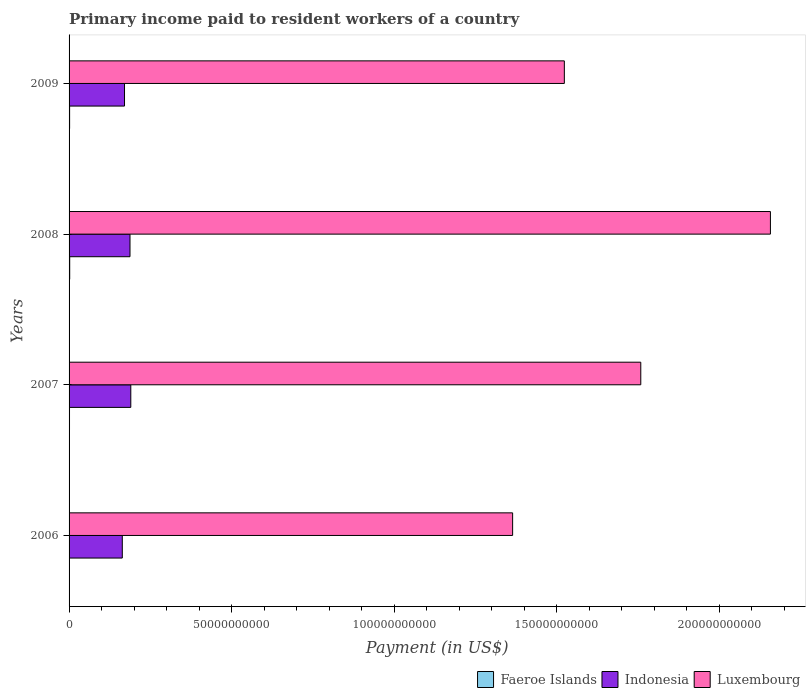How many groups of bars are there?
Your answer should be very brief. 4. Are the number of bars per tick equal to the number of legend labels?
Give a very brief answer. Yes. Are the number of bars on each tick of the Y-axis equal?
Make the answer very short. Yes. How many bars are there on the 4th tick from the top?
Give a very brief answer. 3. How many bars are there on the 3rd tick from the bottom?
Offer a very short reply. 3. What is the amount paid to workers in Luxembourg in 2006?
Provide a succinct answer. 1.36e+11. Across all years, what is the maximum amount paid to workers in Indonesia?
Make the answer very short. 1.90e+1. Across all years, what is the minimum amount paid to workers in Indonesia?
Offer a very short reply. 1.64e+1. In which year was the amount paid to workers in Luxembourg maximum?
Provide a short and direct response. 2008. In which year was the amount paid to workers in Luxembourg minimum?
Offer a very short reply. 2006. What is the total amount paid to workers in Faeroe Islands in the graph?
Provide a succinct answer. 5.95e+08. What is the difference between the amount paid to workers in Luxembourg in 2006 and that in 2009?
Give a very brief answer. -1.59e+1. What is the difference between the amount paid to workers in Indonesia in 2006 and the amount paid to workers in Luxembourg in 2008?
Offer a very short reply. -1.99e+11. What is the average amount paid to workers in Indonesia per year?
Your answer should be very brief. 1.78e+1. In the year 2009, what is the difference between the amount paid to workers in Faeroe Islands and amount paid to workers in Luxembourg?
Give a very brief answer. -1.52e+11. What is the ratio of the amount paid to workers in Luxembourg in 2006 to that in 2009?
Give a very brief answer. 0.9. What is the difference between the highest and the second highest amount paid to workers in Indonesia?
Your answer should be compact. 2.47e+08. What is the difference between the highest and the lowest amount paid to workers in Luxembourg?
Make the answer very short. 7.93e+1. Is the sum of the amount paid to workers in Indonesia in 2007 and 2009 greater than the maximum amount paid to workers in Luxembourg across all years?
Ensure brevity in your answer.  No. What does the 2nd bar from the top in 2009 represents?
Provide a succinct answer. Indonesia. What does the 1st bar from the bottom in 2008 represents?
Your answer should be compact. Faeroe Islands. Is it the case that in every year, the sum of the amount paid to workers in Luxembourg and amount paid to workers in Faeroe Islands is greater than the amount paid to workers in Indonesia?
Provide a short and direct response. Yes. What is the difference between two consecutive major ticks on the X-axis?
Offer a terse response. 5.00e+1. Where does the legend appear in the graph?
Your response must be concise. Bottom right. How many legend labels are there?
Provide a short and direct response. 3. What is the title of the graph?
Your answer should be very brief. Primary income paid to resident workers of a country. What is the label or title of the X-axis?
Provide a short and direct response. Payment (in US$). What is the label or title of the Y-axis?
Offer a very short reply. Years. What is the Payment (in US$) in Faeroe Islands in 2006?
Ensure brevity in your answer.  9.96e+07. What is the Payment (in US$) of Indonesia in 2006?
Give a very brief answer. 1.64e+1. What is the Payment (in US$) in Luxembourg in 2006?
Make the answer very short. 1.36e+11. What is the Payment (in US$) in Faeroe Islands in 2007?
Provide a short and direct response. 1.36e+08. What is the Payment (in US$) of Indonesia in 2007?
Give a very brief answer. 1.90e+1. What is the Payment (in US$) in Luxembourg in 2007?
Give a very brief answer. 1.76e+11. What is the Payment (in US$) in Faeroe Islands in 2008?
Your response must be concise. 1.92e+08. What is the Payment (in US$) in Indonesia in 2008?
Your answer should be very brief. 1.87e+1. What is the Payment (in US$) of Luxembourg in 2008?
Offer a terse response. 2.16e+11. What is the Payment (in US$) of Faeroe Islands in 2009?
Offer a very short reply. 1.67e+08. What is the Payment (in US$) in Indonesia in 2009?
Keep it short and to the point. 1.71e+1. What is the Payment (in US$) of Luxembourg in 2009?
Provide a short and direct response. 1.52e+11. Across all years, what is the maximum Payment (in US$) of Faeroe Islands?
Your answer should be compact. 1.92e+08. Across all years, what is the maximum Payment (in US$) in Indonesia?
Provide a succinct answer. 1.90e+1. Across all years, what is the maximum Payment (in US$) of Luxembourg?
Give a very brief answer. 2.16e+11. Across all years, what is the minimum Payment (in US$) of Faeroe Islands?
Your answer should be very brief. 9.96e+07. Across all years, what is the minimum Payment (in US$) in Indonesia?
Provide a succinct answer. 1.64e+1. Across all years, what is the minimum Payment (in US$) of Luxembourg?
Make the answer very short. 1.36e+11. What is the total Payment (in US$) in Faeroe Islands in the graph?
Offer a very short reply. 5.95e+08. What is the total Payment (in US$) in Indonesia in the graph?
Give a very brief answer. 7.12e+1. What is the total Payment (in US$) of Luxembourg in the graph?
Your response must be concise. 6.81e+11. What is the difference between the Payment (in US$) of Faeroe Islands in 2006 and that in 2007?
Your answer should be very brief. -3.60e+07. What is the difference between the Payment (in US$) in Indonesia in 2006 and that in 2007?
Provide a succinct answer. -2.62e+09. What is the difference between the Payment (in US$) in Luxembourg in 2006 and that in 2007?
Provide a succinct answer. -3.94e+1. What is the difference between the Payment (in US$) of Faeroe Islands in 2006 and that in 2008?
Provide a succinct answer. -9.29e+07. What is the difference between the Payment (in US$) of Indonesia in 2006 and that in 2008?
Offer a very short reply. -2.37e+09. What is the difference between the Payment (in US$) in Luxembourg in 2006 and that in 2008?
Keep it short and to the point. -7.93e+1. What is the difference between the Payment (in US$) in Faeroe Islands in 2006 and that in 2009?
Give a very brief answer. -6.74e+07. What is the difference between the Payment (in US$) in Indonesia in 2006 and that in 2009?
Your response must be concise. -6.84e+08. What is the difference between the Payment (in US$) of Luxembourg in 2006 and that in 2009?
Give a very brief answer. -1.59e+1. What is the difference between the Payment (in US$) of Faeroe Islands in 2007 and that in 2008?
Provide a succinct answer. -5.69e+07. What is the difference between the Payment (in US$) in Indonesia in 2007 and that in 2008?
Offer a very short reply. 2.47e+08. What is the difference between the Payment (in US$) in Luxembourg in 2007 and that in 2008?
Your answer should be compact. -3.99e+1. What is the difference between the Payment (in US$) of Faeroe Islands in 2007 and that in 2009?
Your answer should be compact. -3.14e+07. What is the difference between the Payment (in US$) in Indonesia in 2007 and that in 2009?
Your answer should be compact. 1.93e+09. What is the difference between the Payment (in US$) in Luxembourg in 2007 and that in 2009?
Your answer should be very brief. 2.35e+1. What is the difference between the Payment (in US$) in Faeroe Islands in 2008 and that in 2009?
Make the answer very short. 2.55e+07. What is the difference between the Payment (in US$) in Indonesia in 2008 and that in 2009?
Provide a short and direct response. 1.69e+09. What is the difference between the Payment (in US$) of Luxembourg in 2008 and that in 2009?
Give a very brief answer. 6.34e+1. What is the difference between the Payment (in US$) in Faeroe Islands in 2006 and the Payment (in US$) in Indonesia in 2007?
Your answer should be compact. -1.89e+1. What is the difference between the Payment (in US$) of Faeroe Islands in 2006 and the Payment (in US$) of Luxembourg in 2007?
Ensure brevity in your answer.  -1.76e+11. What is the difference between the Payment (in US$) of Indonesia in 2006 and the Payment (in US$) of Luxembourg in 2007?
Your answer should be compact. -1.60e+11. What is the difference between the Payment (in US$) of Faeroe Islands in 2006 and the Payment (in US$) of Indonesia in 2008?
Provide a succinct answer. -1.86e+1. What is the difference between the Payment (in US$) of Faeroe Islands in 2006 and the Payment (in US$) of Luxembourg in 2008?
Ensure brevity in your answer.  -2.16e+11. What is the difference between the Payment (in US$) in Indonesia in 2006 and the Payment (in US$) in Luxembourg in 2008?
Offer a terse response. -1.99e+11. What is the difference between the Payment (in US$) of Faeroe Islands in 2006 and the Payment (in US$) of Indonesia in 2009?
Provide a short and direct response. -1.70e+1. What is the difference between the Payment (in US$) in Faeroe Islands in 2006 and the Payment (in US$) in Luxembourg in 2009?
Your response must be concise. -1.52e+11. What is the difference between the Payment (in US$) in Indonesia in 2006 and the Payment (in US$) in Luxembourg in 2009?
Give a very brief answer. -1.36e+11. What is the difference between the Payment (in US$) of Faeroe Islands in 2007 and the Payment (in US$) of Indonesia in 2008?
Your response must be concise. -1.86e+1. What is the difference between the Payment (in US$) in Faeroe Islands in 2007 and the Payment (in US$) in Luxembourg in 2008?
Keep it short and to the point. -2.16e+11. What is the difference between the Payment (in US$) in Indonesia in 2007 and the Payment (in US$) in Luxembourg in 2008?
Keep it short and to the point. -1.97e+11. What is the difference between the Payment (in US$) of Faeroe Islands in 2007 and the Payment (in US$) of Indonesia in 2009?
Provide a short and direct response. -1.69e+1. What is the difference between the Payment (in US$) in Faeroe Islands in 2007 and the Payment (in US$) in Luxembourg in 2009?
Offer a terse response. -1.52e+11. What is the difference between the Payment (in US$) of Indonesia in 2007 and the Payment (in US$) of Luxembourg in 2009?
Provide a short and direct response. -1.33e+11. What is the difference between the Payment (in US$) in Faeroe Islands in 2008 and the Payment (in US$) in Indonesia in 2009?
Ensure brevity in your answer.  -1.69e+1. What is the difference between the Payment (in US$) of Faeroe Islands in 2008 and the Payment (in US$) of Luxembourg in 2009?
Your response must be concise. -1.52e+11. What is the difference between the Payment (in US$) in Indonesia in 2008 and the Payment (in US$) in Luxembourg in 2009?
Your response must be concise. -1.34e+11. What is the average Payment (in US$) of Faeroe Islands per year?
Provide a succinct answer. 1.49e+08. What is the average Payment (in US$) of Indonesia per year?
Your response must be concise. 1.78e+1. What is the average Payment (in US$) of Luxembourg per year?
Give a very brief answer. 1.70e+11. In the year 2006, what is the difference between the Payment (in US$) in Faeroe Islands and Payment (in US$) in Indonesia?
Keep it short and to the point. -1.63e+1. In the year 2006, what is the difference between the Payment (in US$) in Faeroe Islands and Payment (in US$) in Luxembourg?
Offer a very short reply. -1.36e+11. In the year 2006, what is the difference between the Payment (in US$) of Indonesia and Payment (in US$) of Luxembourg?
Your response must be concise. -1.20e+11. In the year 2007, what is the difference between the Payment (in US$) of Faeroe Islands and Payment (in US$) of Indonesia?
Offer a very short reply. -1.89e+1. In the year 2007, what is the difference between the Payment (in US$) in Faeroe Islands and Payment (in US$) in Luxembourg?
Your answer should be very brief. -1.76e+11. In the year 2007, what is the difference between the Payment (in US$) of Indonesia and Payment (in US$) of Luxembourg?
Your answer should be very brief. -1.57e+11. In the year 2008, what is the difference between the Payment (in US$) of Faeroe Islands and Payment (in US$) of Indonesia?
Ensure brevity in your answer.  -1.86e+1. In the year 2008, what is the difference between the Payment (in US$) in Faeroe Islands and Payment (in US$) in Luxembourg?
Your response must be concise. -2.16e+11. In the year 2008, what is the difference between the Payment (in US$) of Indonesia and Payment (in US$) of Luxembourg?
Your response must be concise. -1.97e+11. In the year 2009, what is the difference between the Payment (in US$) of Faeroe Islands and Payment (in US$) of Indonesia?
Make the answer very short. -1.69e+1. In the year 2009, what is the difference between the Payment (in US$) in Faeroe Islands and Payment (in US$) in Luxembourg?
Provide a succinct answer. -1.52e+11. In the year 2009, what is the difference between the Payment (in US$) of Indonesia and Payment (in US$) of Luxembourg?
Your answer should be compact. -1.35e+11. What is the ratio of the Payment (in US$) in Faeroe Islands in 2006 to that in 2007?
Keep it short and to the point. 0.73. What is the ratio of the Payment (in US$) of Indonesia in 2006 to that in 2007?
Your response must be concise. 0.86. What is the ratio of the Payment (in US$) of Luxembourg in 2006 to that in 2007?
Give a very brief answer. 0.78. What is the ratio of the Payment (in US$) of Faeroe Islands in 2006 to that in 2008?
Offer a terse response. 0.52. What is the ratio of the Payment (in US$) of Indonesia in 2006 to that in 2008?
Provide a short and direct response. 0.87. What is the ratio of the Payment (in US$) in Luxembourg in 2006 to that in 2008?
Keep it short and to the point. 0.63. What is the ratio of the Payment (in US$) in Faeroe Islands in 2006 to that in 2009?
Your response must be concise. 0.6. What is the ratio of the Payment (in US$) of Indonesia in 2006 to that in 2009?
Provide a succinct answer. 0.96. What is the ratio of the Payment (in US$) in Luxembourg in 2006 to that in 2009?
Provide a succinct answer. 0.9. What is the ratio of the Payment (in US$) of Faeroe Islands in 2007 to that in 2008?
Make the answer very short. 0.7. What is the ratio of the Payment (in US$) in Indonesia in 2007 to that in 2008?
Keep it short and to the point. 1.01. What is the ratio of the Payment (in US$) in Luxembourg in 2007 to that in 2008?
Offer a terse response. 0.82. What is the ratio of the Payment (in US$) in Faeroe Islands in 2007 to that in 2009?
Provide a succinct answer. 0.81. What is the ratio of the Payment (in US$) of Indonesia in 2007 to that in 2009?
Offer a terse response. 1.11. What is the ratio of the Payment (in US$) of Luxembourg in 2007 to that in 2009?
Your answer should be compact. 1.15. What is the ratio of the Payment (in US$) of Faeroe Islands in 2008 to that in 2009?
Keep it short and to the point. 1.15. What is the ratio of the Payment (in US$) of Indonesia in 2008 to that in 2009?
Provide a succinct answer. 1.1. What is the ratio of the Payment (in US$) in Luxembourg in 2008 to that in 2009?
Provide a succinct answer. 1.42. What is the difference between the highest and the second highest Payment (in US$) of Faeroe Islands?
Make the answer very short. 2.55e+07. What is the difference between the highest and the second highest Payment (in US$) of Indonesia?
Make the answer very short. 2.47e+08. What is the difference between the highest and the second highest Payment (in US$) in Luxembourg?
Your response must be concise. 3.99e+1. What is the difference between the highest and the lowest Payment (in US$) of Faeroe Islands?
Make the answer very short. 9.29e+07. What is the difference between the highest and the lowest Payment (in US$) in Indonesia?
Keep it short and to the point. 2.62e+09. What is the difference between the highest and the lowest Payment (in US$) in Luxembourg?
Your response must be concise. 7.93e+1. 